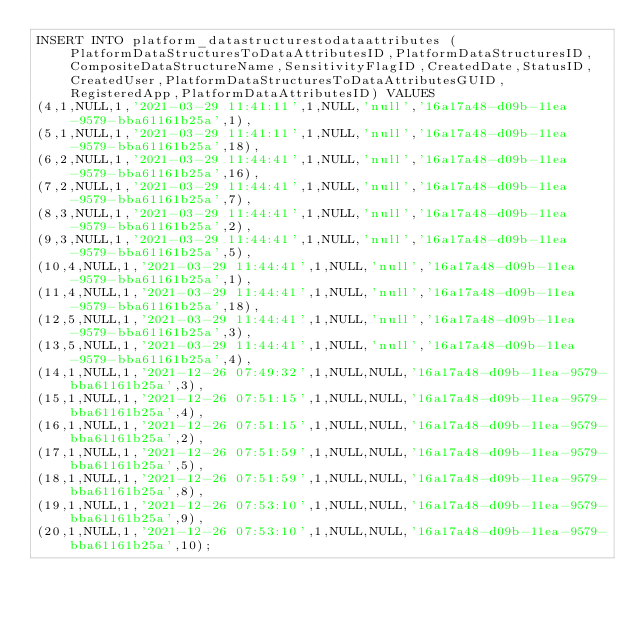<code> <loc_0><loc_0><loc_500><loc_500><_SQL_>INSERT INTO platform_datastructurestodataattributes (PlatformDataStructuresToDataAttributesID,PlatformDataStructuresID,CompositeDataStructureName,SensitivityFlagID,CreatedDate,StatusID,CreatedUser,PlatformDataStructuresToDataAttributesGUID,RegisteredApp,PlatformDataAttributesID) VALUES
(4,1,NULL,1,'2021-03-29 11:41:11',1,NULL,'null','16a17a48-d09b-11ea-9579-bba61161b25a',1),
(5,1,NULL,1,'2021-03-29 11:41:11',1,NULL,'null','16a17a48-d09b-11ea-9579-bba61161b25a',18),
(6,2,NULL,1,'2021-03-29 11:44:41',1,NULL,'null','16a17a48-d09b-11ea-9579-bba61161b25a',16),
(7,2,NULL,1,'2021-03-29 11:44:41',1,NULL,'null','16a17a48-d09b-11ea-9579-bba61161b25a',7),
(8,3,NULL,1,'2021-03-29 11:44:41',1,NULL,'null','16a17a48-d09b-11ea-9579-bba61161b25a',2),
(9,3,NULL,1,'2021-03-29 11:44:41',1,NULL,'null','16a17a48-d09b-11ea-9579-bba61161b25a',5),
(10,4,NULL,1,'2021-03-29 11:44:41',1,NULL,'null','16a17a48-d09b-11ea-9579-bba61161b25a',1),
(11,4,NULL,1,'2021-03-29 11:44:41',1,NULL,'null','16a17a48-d09b-11ea-9579-bba61161b25a',18),
(12,5,NULL,1,'2021-03-29 11:44:41',1,NULL,'null','16a17a48-d09b-11ea-9579-bba61161b25a',3),
(13,5,NULL,1,'2021-03-29 11:44:41',1,NULL,'null','16a17a48-d09b-11ea-9579-bba61161b25a',4),
(14,1,NULL,1,'2021-12-26 07:49:32',1,NULL,NULL,'16a17a48-d09b-11ea-9579-bba61161b25a',3),
(15,1,NULL,1,'2021-12-26 07:51:15',1,NULL,NULL,'16a17a48-d09b-11ea-9579-bba61161b25a',4),
(16,1,NULL,1,'2021-12-26 07:51:15',1,NULL,NULL,'16a17a48-d09b-11ea-9579-bba61161b25a',2),
(17,1,NULL,1,'2021-12-26 07:51:59',1,NULL,NULL,'16a17a48-d09b-11ea-9579-bba61161b25a',5),
(18,1,NULL,1,'2021-12-26 07:51:59',1,NULL,NULL,'16a17a48-d09b-11ea-9579-bba61161b25a',8),
(19,1,NULL,1,'2021-12-26 07:53:10',1,NULL,NULL,'16a17a48-d09b-11ea-9579-bba61161b25a',9),
(20,1,NULL,1,'2021-12-26 07:53:10',1,NULL,NULL,'16a17a48-d09b-11ea-9579-bba61161b25a',10);</code> 